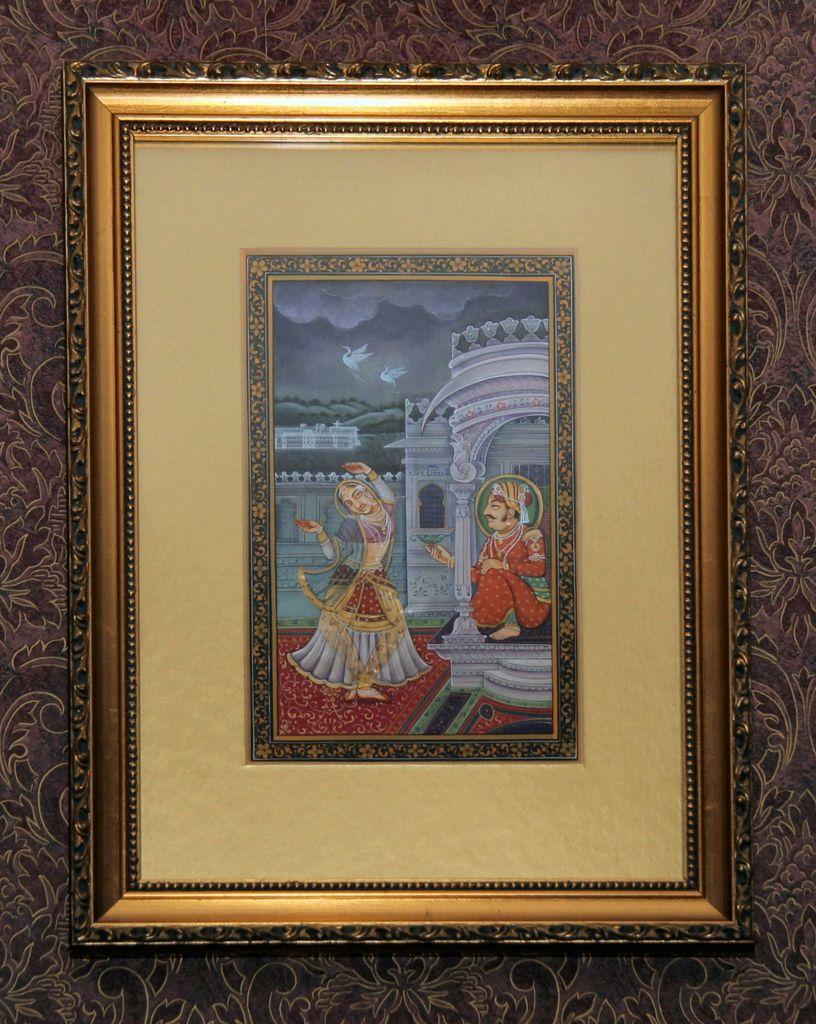Can you describe this image briefly? Here on the wall there is photo frame in it there is man and a woman is present. 